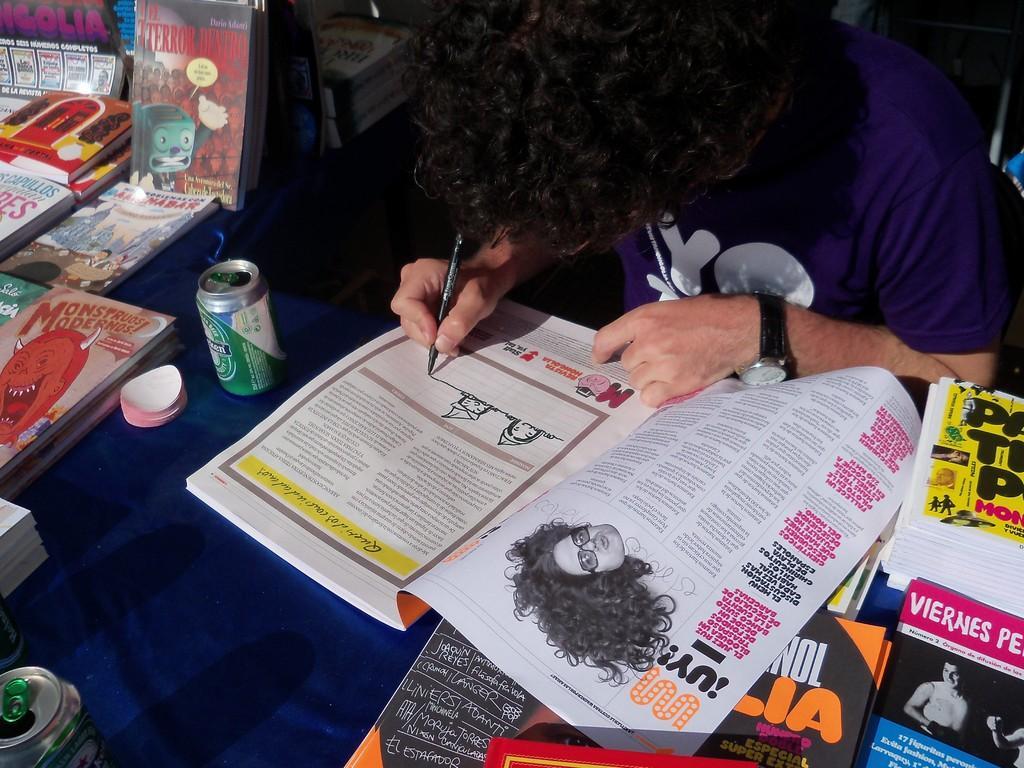How would you summarize this image in a sentence or two? In this image we can see books, tin and other objects on the table, there is a person sitting and holding a pen and drawing on a book. 